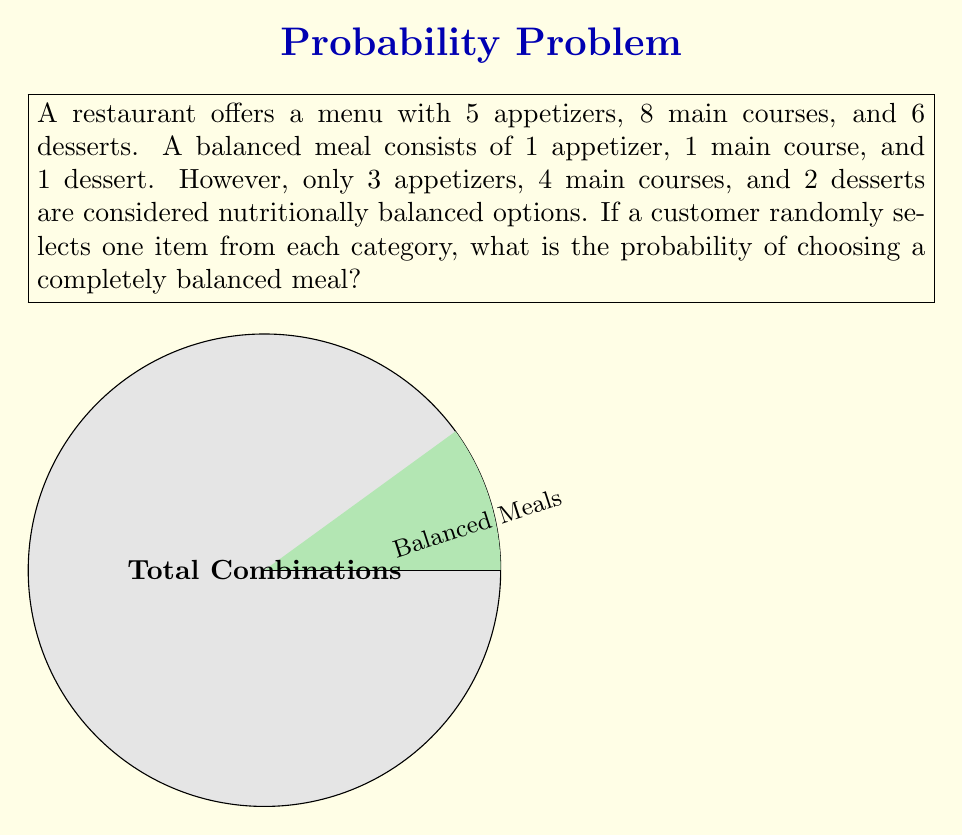Could you help me with this problem? Let's approach this step-by-step:

1) First, we need to calculate the total number of possible meal combinations:
   $$\text{Total combinations} = 5 \times 8 \times 6 = 240$$

2) Now, let's calculate the number of balanced meal combinations:
   $$\text{Balanced combinations} = 3 \times 4 \times 2 = 24$$

3) The probability of selecting a balanced meal is the number of favorable outcomes divided by the total number of possible outcomes:

   $$P(\text{balanced meal}) = \frac{\text{Balanced combinations}}{\text{Total combinations}}$$

4) Substituting our values:

   $$P(\text{balanced meal}) = \frac{24}{240} = \frac{1}{10} = 0.1$$

5) Therefore, the probability of randomly selecting a completely balanced meal is $\frac{1}{10}$ or 0.1 or 10%.

This problem demonstrates the application of the fundamental counting principle and basic probability concepts in a nutritional context, which aligns with the given persona of a seasoned nutritionist.
Answer: $\frac{1}{10}$ 